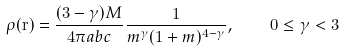Convert formula to latex. <formula><loc_0><loc_0><loc_500><loc_500>\rho ( \mathbf r ) = \frac { ( 3 - \gamma ) M } { 4 \pi a b c } \frac { 1 } { m ^ { \gamma } ( 1 + m ) ^ { 4 - \gamma } } , \quad 0 \leq \gamma < 3</formula> 